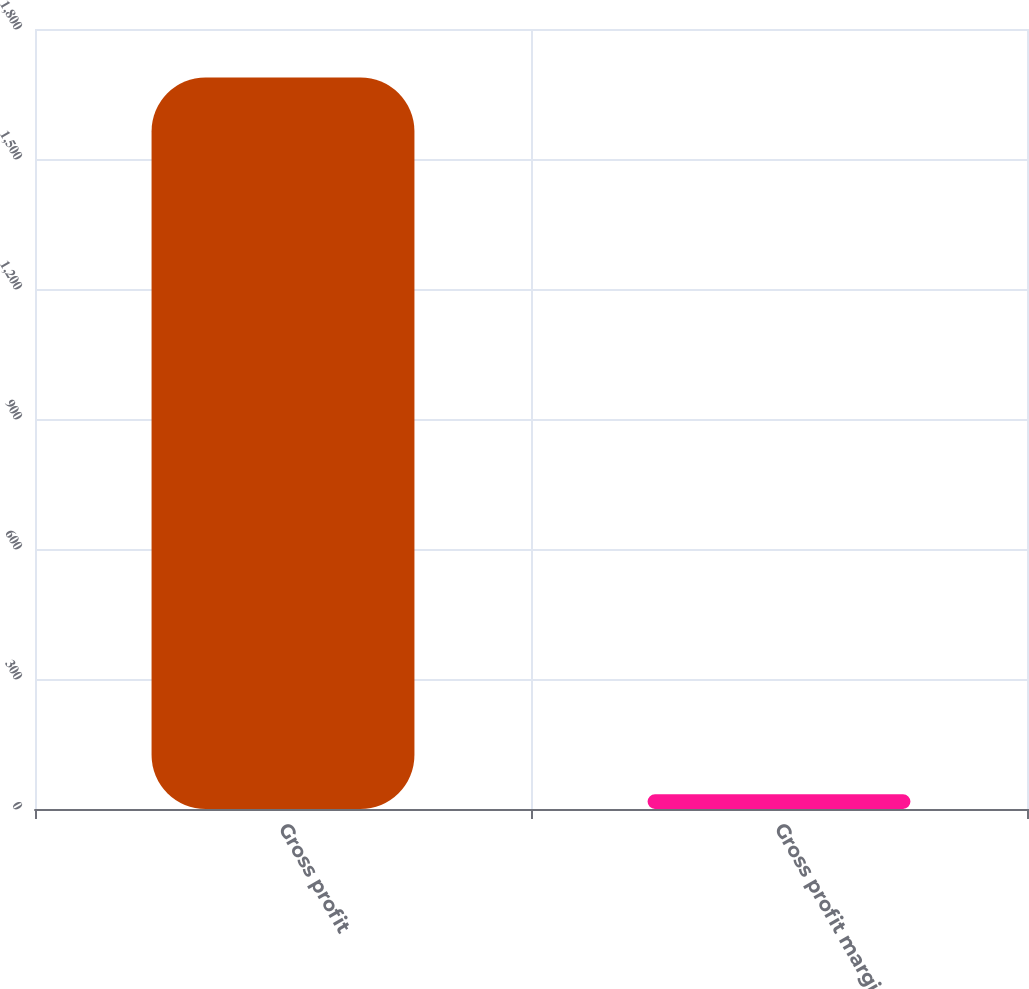Convert chart. <chart><loc_0><loc_0><loc_500><loc_500><bar_chart><fcel>Gross profit<fcel>Gross profit margin<nl><fcel>1688.1<fcel>34.1<nl></chart> 